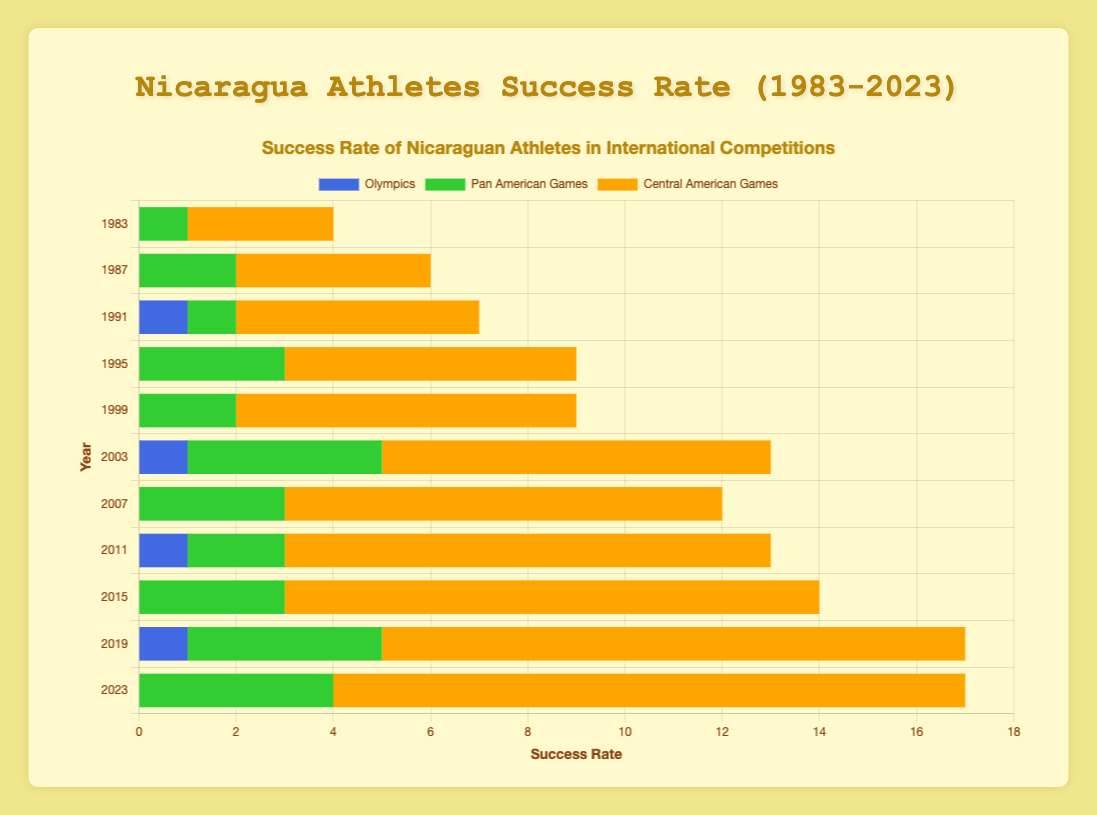Which year had the highest success rate in the Central American Games? To find out which year had the highest success rate in the Central American Games, we look for the longest bar segment colored for the Central American Games, which is indicated by an orange color. By checking each year's orange segment, 2023 shows the longest segment with a success rate of 13.
Answer: 2023 How many total successes were recorded in the Pan American Games between 1983 and 2023? To find the total success in the Pan American Games, sum up all the green bar segments for each year: 1 (1983) + 2 (1987) + 1 (1991) + 3 (1995) + 2 (1999) + 4 (2003) + 3 (2007) + 2 (2011) + 3 (2015) + 4 (2019) + 4 (2023). This equals 29.
Answer: 29 Which year showed an improvement in success rate in all three competitions compared to the previous competition year (specifically comparing 1987 to 1983)? We compare the success rate changes for the Olympics, Pan American Games, and Central American Games from 1983 to 1987. In 1983: Olympics (0), Pan American Games (1), Central American Games (3); in 1987: Olympics (0), Pan American Games (2), Central American Games (4). Although there was no improvement in the Olympics, there was an improvement in the Pan American Games (from 1 to 2) and Central American Games (from 3 to 4). Therefore, 1987 did not show improvement in all three competitions. No year has improvement in all three categories, so this question has no valid answer.
Answer: N/A What is the average success rate for Nicaragua in the Central American Games from 1983 to 2023? To find the average success rate in the Central American Games, sum the rates for all given years and divide by the number of years. The sum is 3 + 4 + 5 + 6 + 7 + 8 + 9 + 10 + 11 + 12 + 13 = 88. There are 11 years considered, so the average success rate is 88 / 11 = 8.
Answer: 8 How does the success rate in the Olympics for the year 2019 compare to the year 2011? Looking at the figure, the year 2019 has a success rate of 1 for the Olympics (blue segment), and 2011 also has a success rate of 1 for the Olympics. Therefore, the success rate in the Olympics for both years is equal.
Answer: equal Which year had no recorded successes in the Olympics while having at least one success in both the Pan American Games and Central American Games? Checking the figure, 1983, 1987, 1995, and 2023 had no successes in the Olympics. From these, both 1983 (Pan American Games = 1, Central American Games=3), 1987 (Pan American Games = 2, Central American Games=4), 1995 (Pan American Games = 3, Central American Games=6) and 2023 (Pan American Games = 4, Central American Games = 13) meet the condition of having at least one success in the other two competitions.
Answer: 1983, 1987, 1995, 2023 What is the combined success rate in all competitions for 2003? To find the combined success rate for all competitions in 2003, sum up all the segments for that year: Olympics (1) + Pan American Games (4) + Central American Games (8). This gives us a total success rate of 1 + 4 + 8 = 13.
Answer: 13 What trend can be observed about the Central American Games success rate from 1983 to 2023? Observing the orange bar segments through the years, there is a clear upward trend in the Central American Games' success rate, with each year showing an increase over the previous one.
Answer: Upward trend 